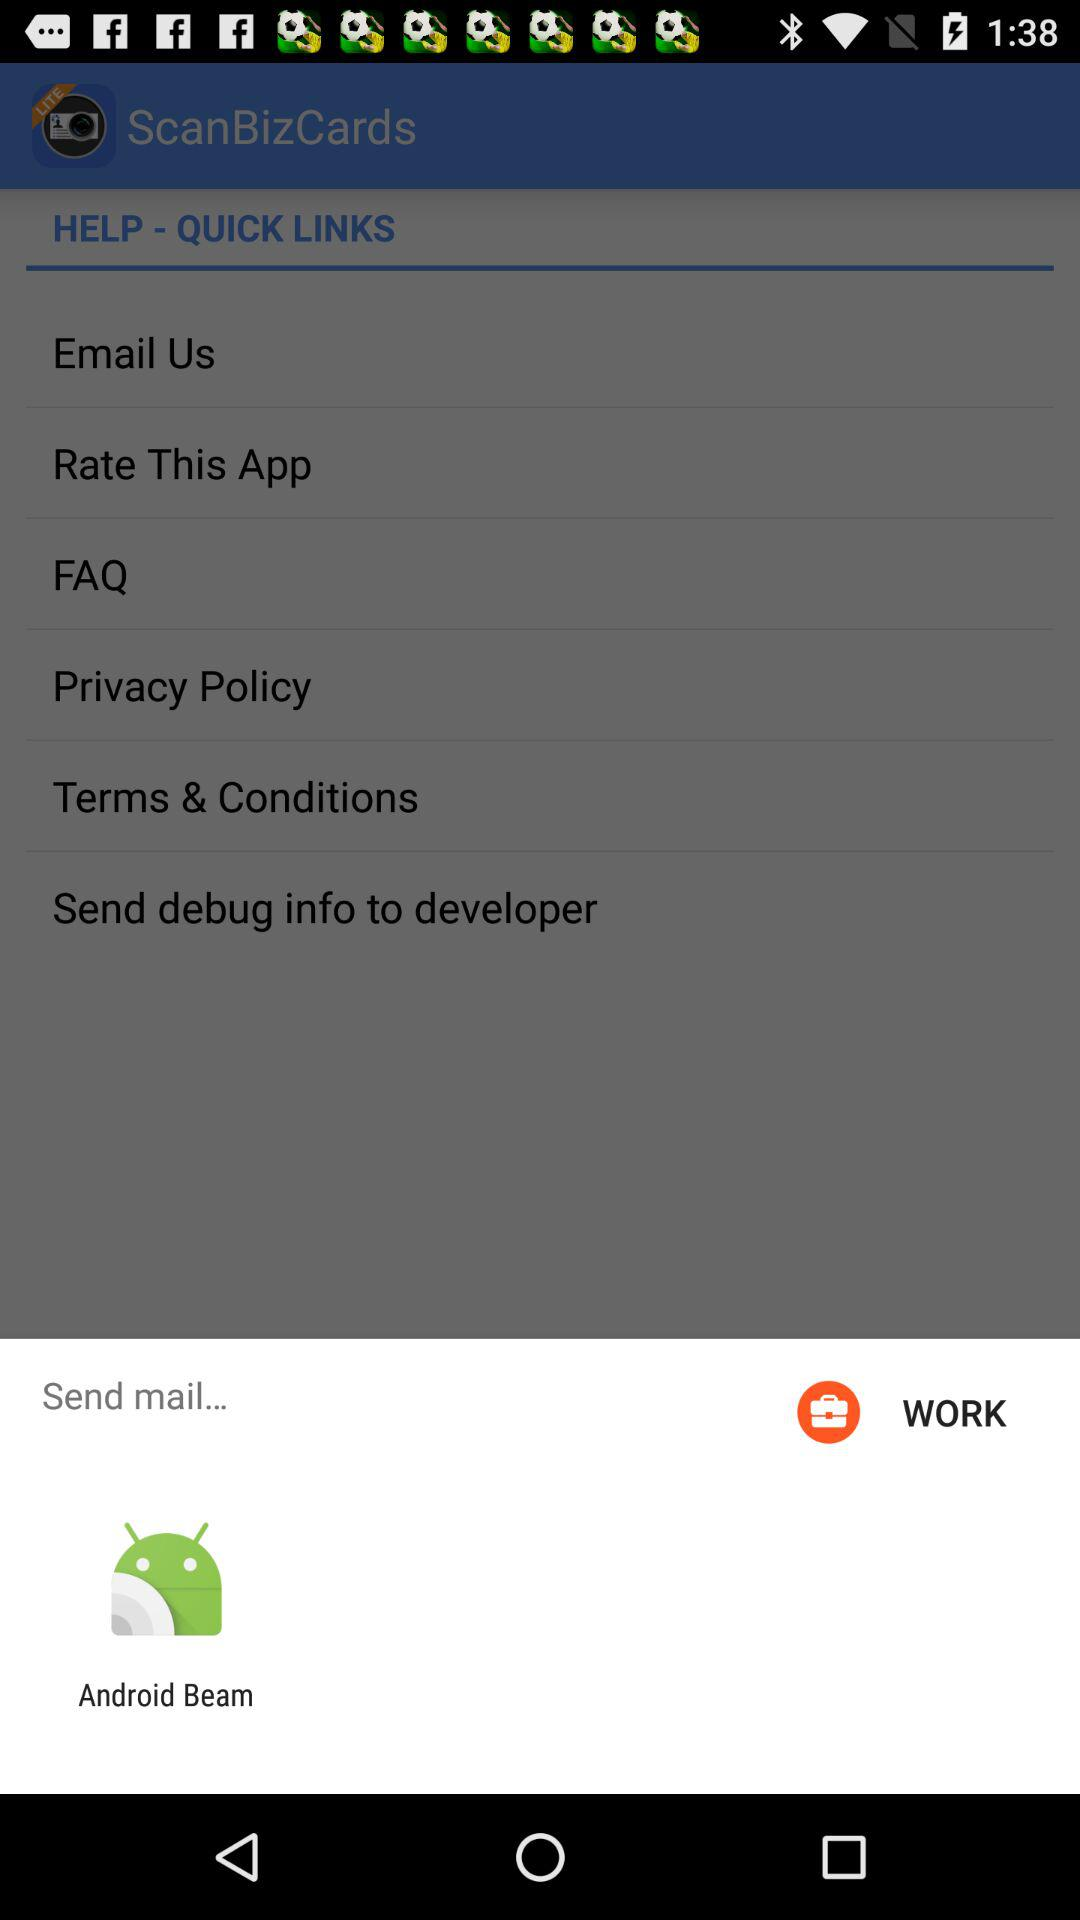What can the mail be sent through? The mail can be sent through "Android Beam". 